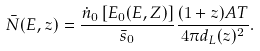Convert formula to latex. <formula><loc_0><loc_0><loc_500><loc_500>\bar { N } ( E , z ) = \frac { \dot { n } _ { 0 } \left [ E _ { 0 } ( E , Z ) \right ] } { { \bar { s } } _ { 0 } } \frac { ( 1 + z ) A T } { 4 \pi d _ { L } ( z ) ^ { 2 } } .</formula> 